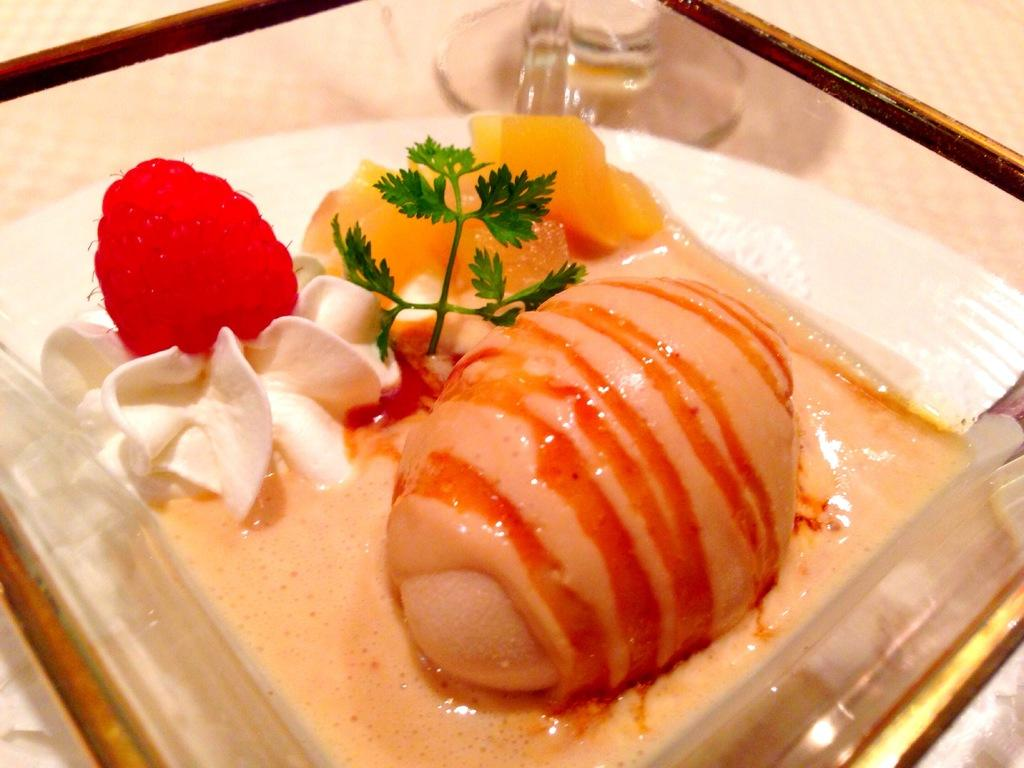What type of items can be seen in the image? The image contains food. What verse can be heard recited by the thumb in the image? There is no thumb or verse present in the image; it only contains food. 